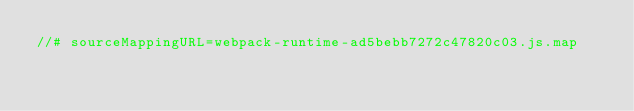Convert code to text. <code><loc_0><loc_0><loc_500><loc_500><_JavaScript_>//# sourceMappingURL=webpack-runtime-ad5bebb7272c47820c03.js.map</code> 